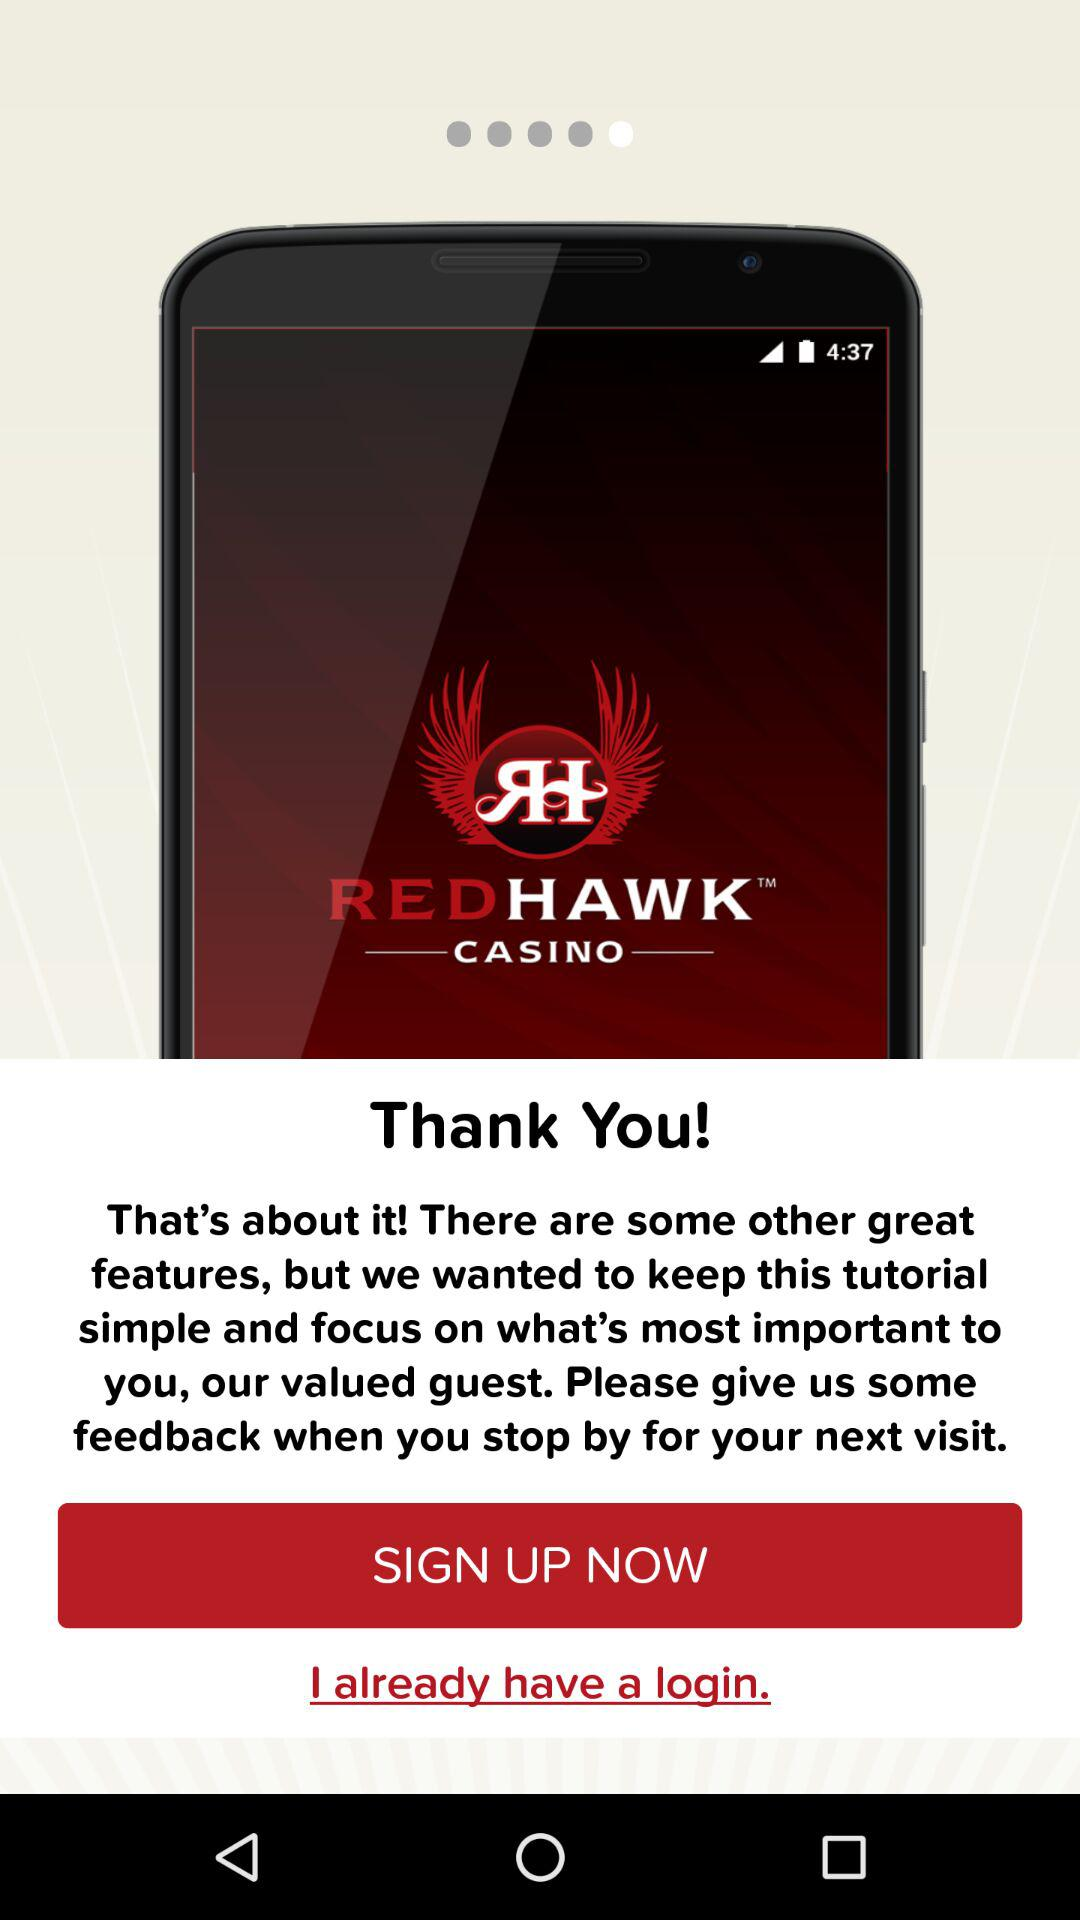What is the name of the application? The name of the application is "myRedHawk". 